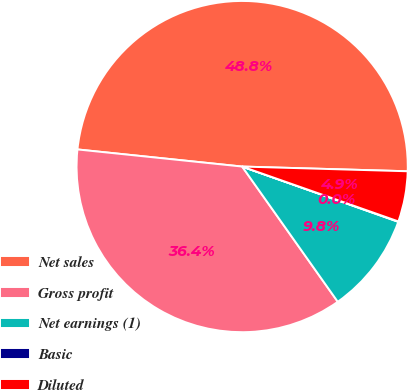Convert chart. <chart><loc_0><loc_0><loc_500><loc_500><pie_chart><fcel>Net sales<fcel>Gross profit<fcel>Net earnings (1)<fcel>Basic<fcel>Diluted<nl><fcel>48.8%<fcel>36.44%<fcel>9.79%<fcel>0.04%<fcel>4.92%<nl></chart> 